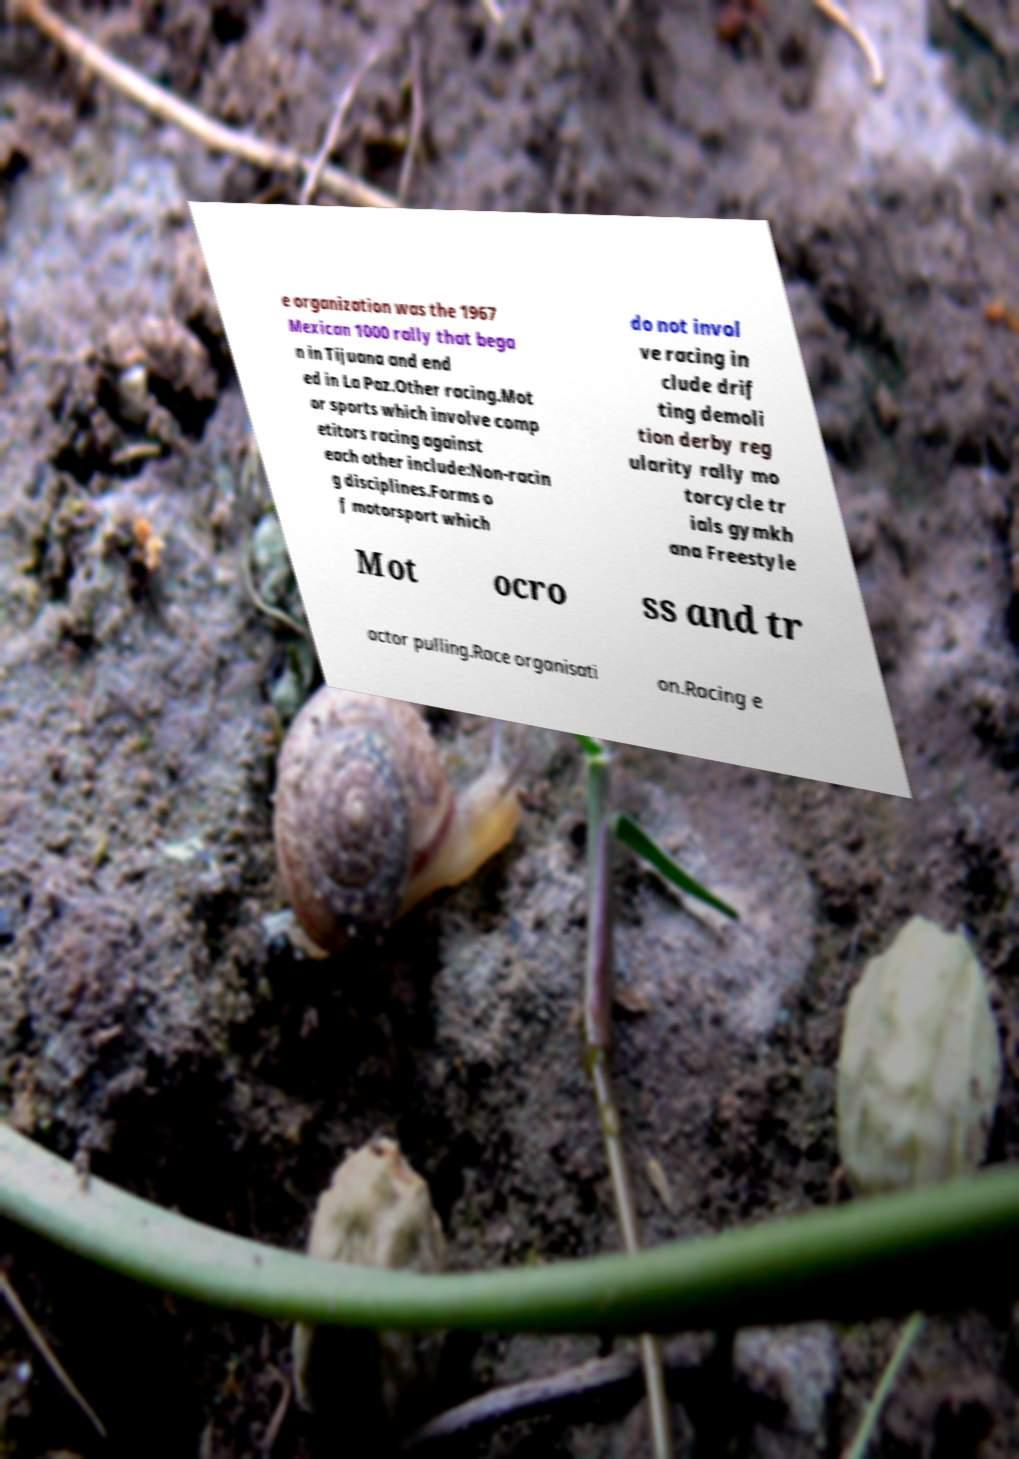I need the written content from this picture converted into text. Can you do that? e organization was the 1967 Mexican 1000 rally that bega n in Tijuana and end ed in La Paz.Other racing.Mot or sports which involve comp etitors racing against each other include:Non-racin g disciplines.Forms o f motorsport which do not invol ve racing in clude drif ting demoli tion derby reg ularity rally mo torcycle tr ials gymkh ana Freestyle Mot ocro ss and tr actor pulling.Race organisati on.Racing e 